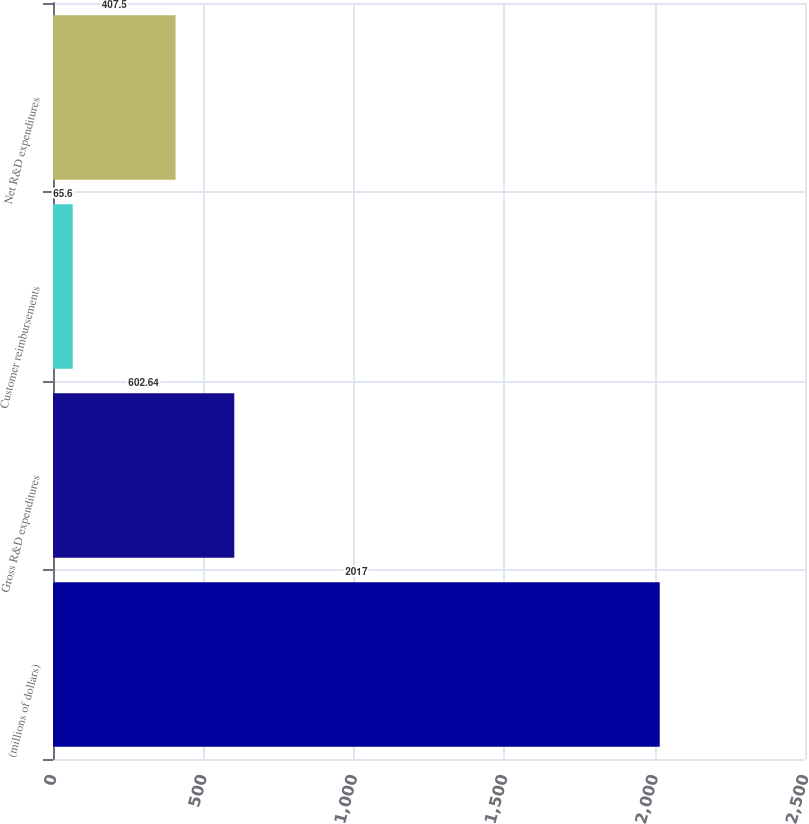Convert chart to OTSL. <chart><loc_0><loc_0><loc_500><loc_500><bar_chart><fcel>(millions of dollars)<fcel>Gross R&D expenditures<fcel>Customer reimbursements<fcel>Net R&D expenditures<nl><fcel>2017<fcel>602.64<fcel>65.6<fcel>407.5<nl></chart> 